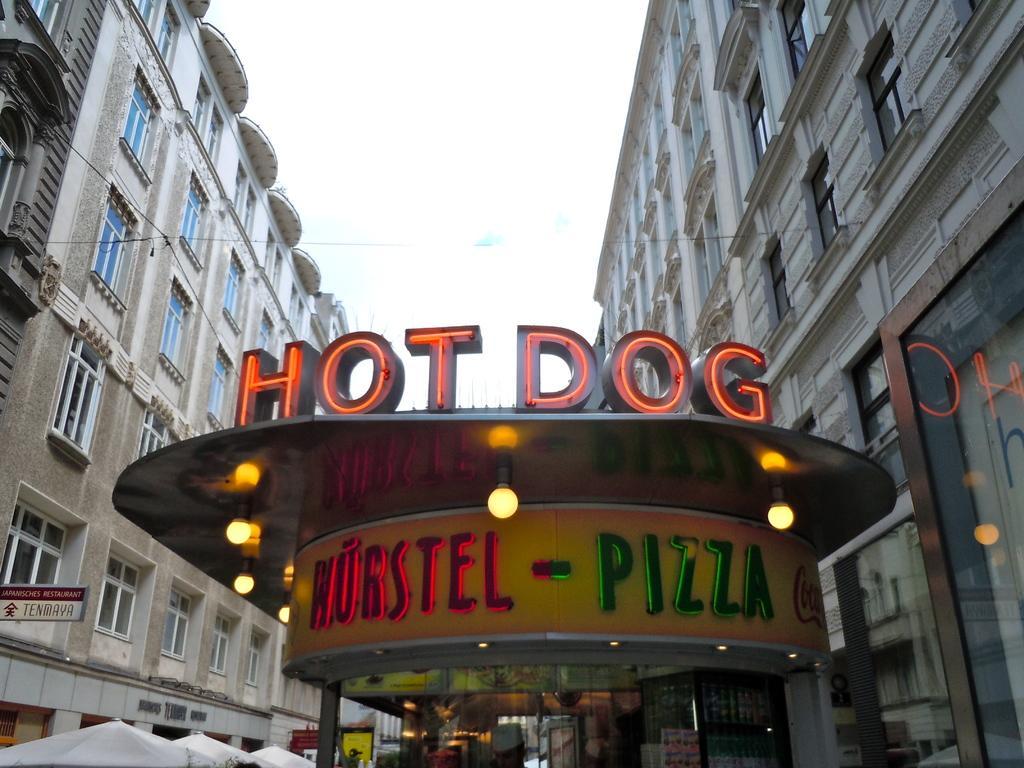How would you summarize this image in a sentence or two? In this image there are buildings. At the bottom there is a store and we can see lights. In the background there is sky. On the left there are tents. 